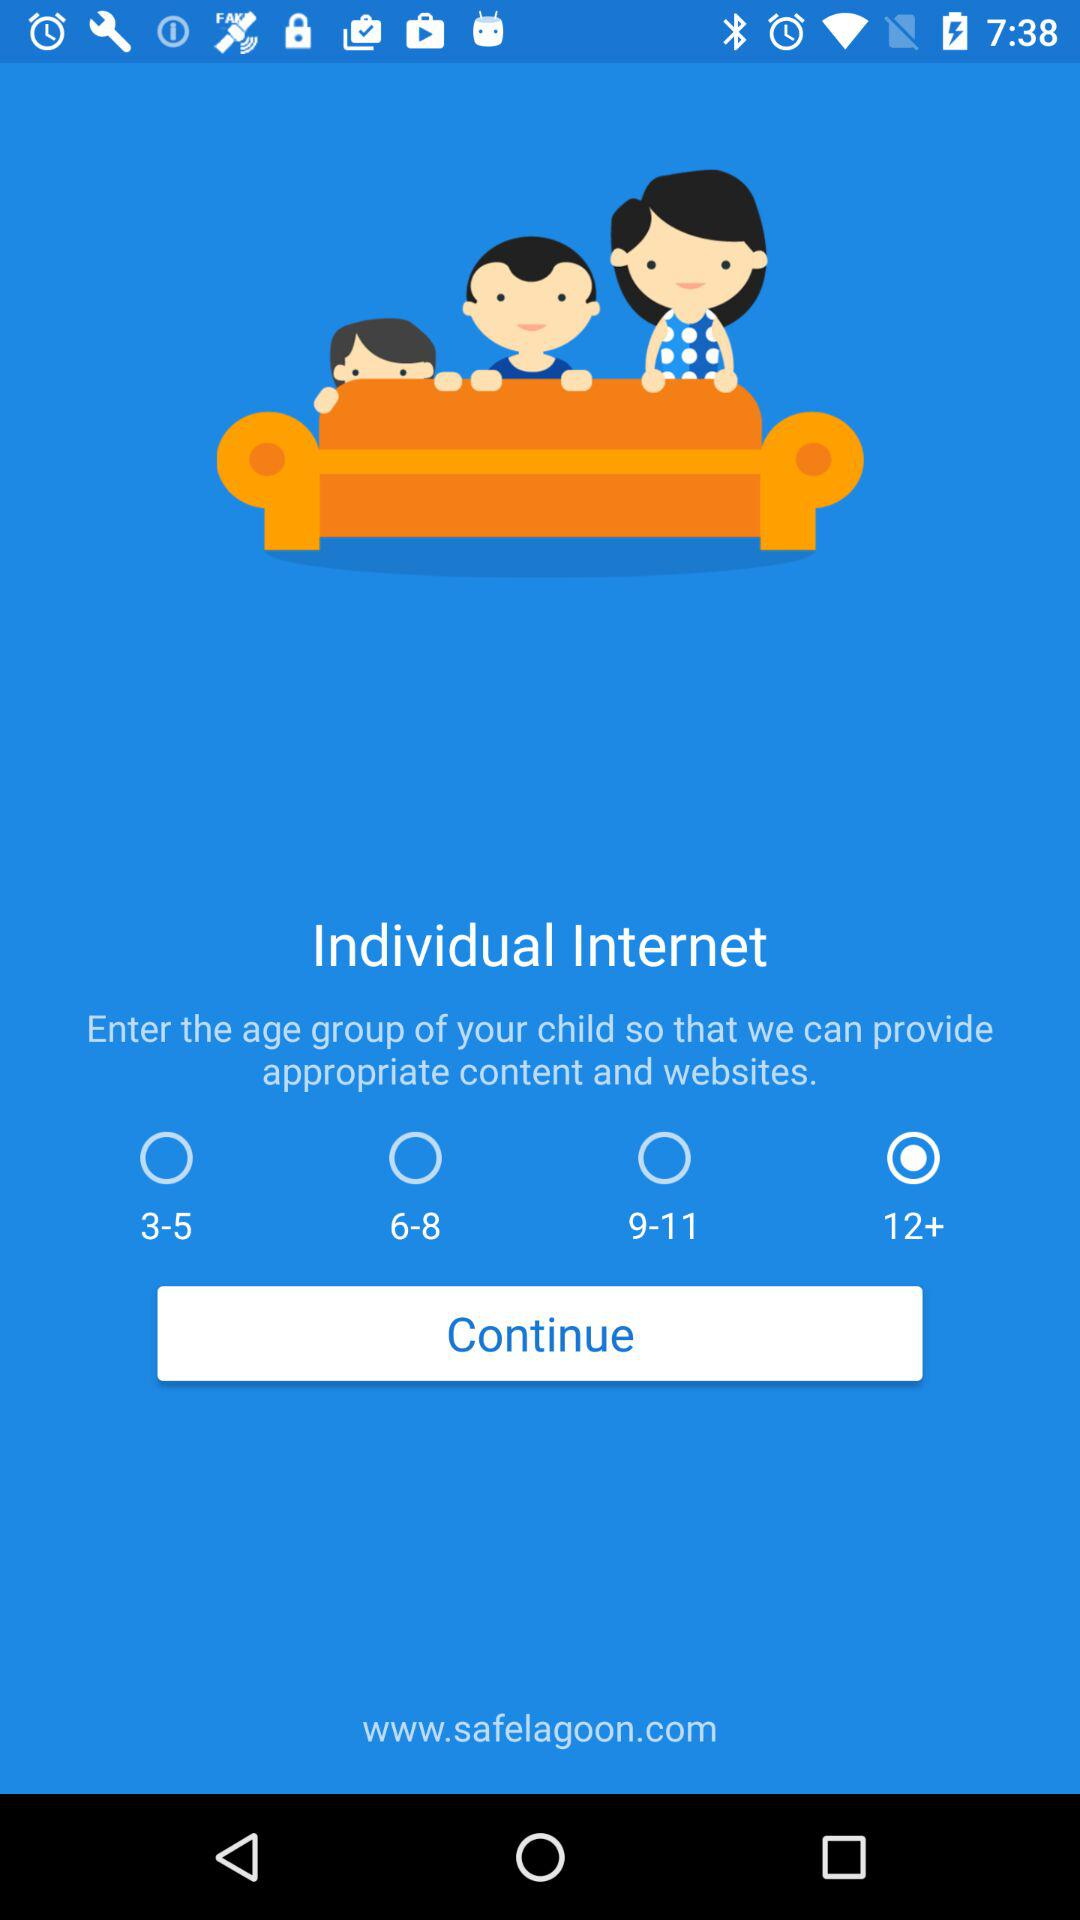How many age groups are between 3-11?
Answer the question using a single word or phrase. 3 